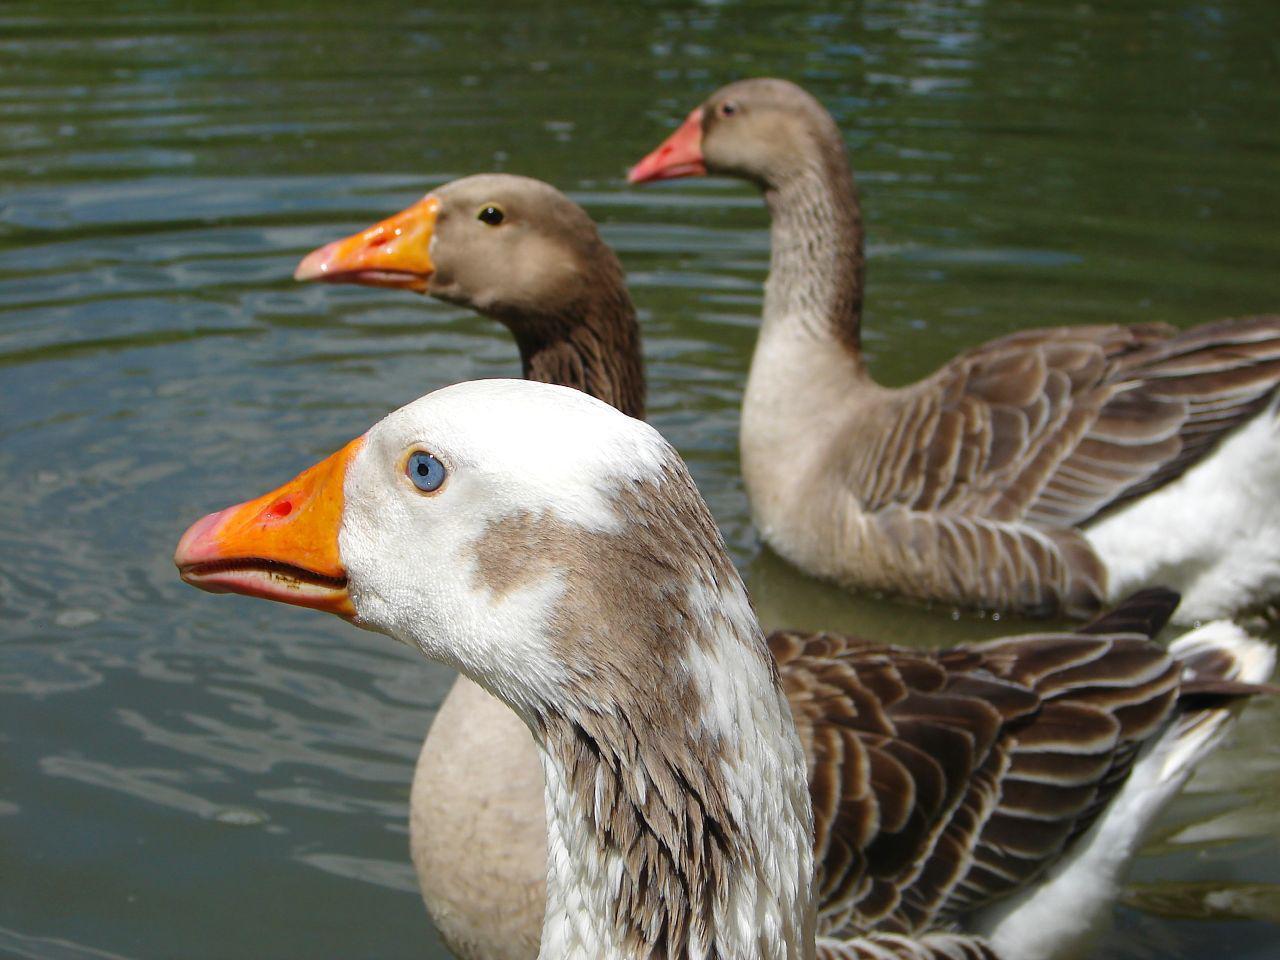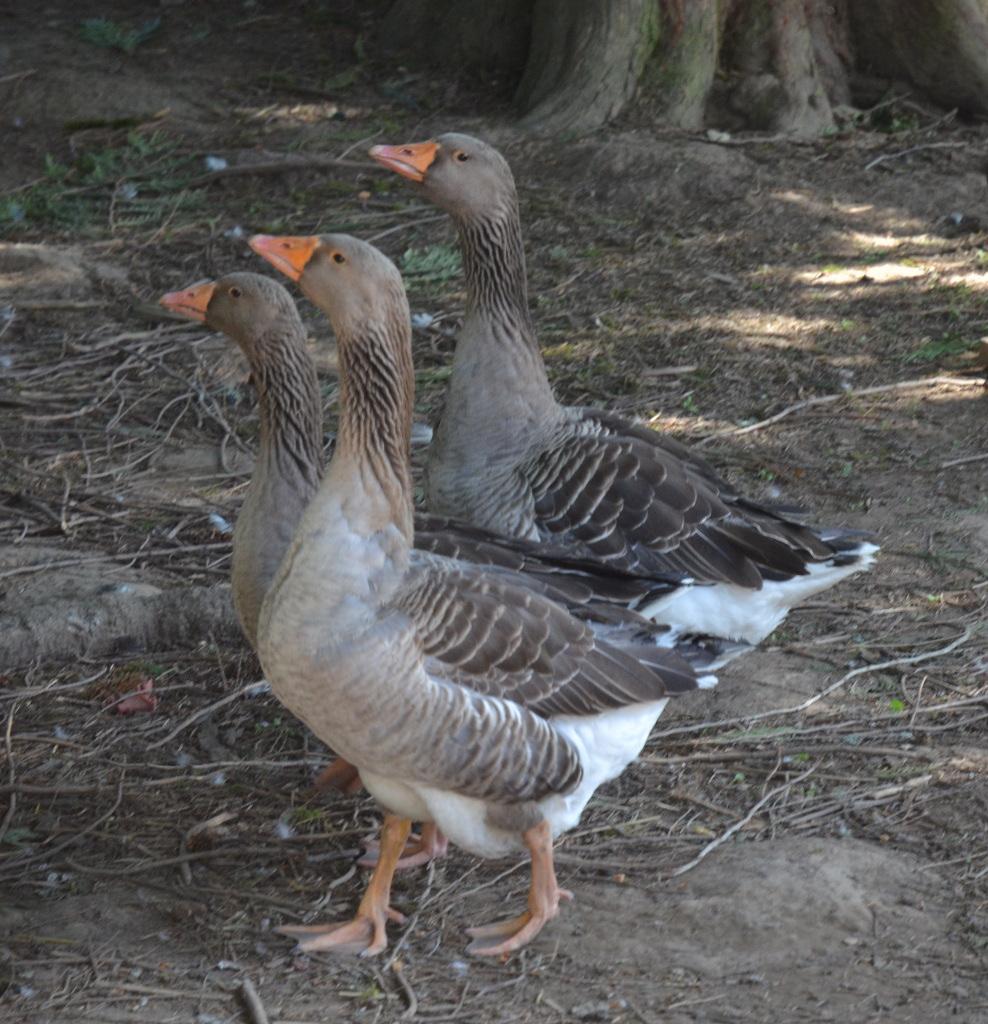The first image is the image on the left, the second image is the image on the right. Assess this claim about the two images: "There are exactly two ducks.". Correct or not? Answer yes or no. No. The first image is the image on the left, the second image is the image on the right. For the images displayed, is the sentence "An image shows one black-beaked goose standing on the water's edge." factually correct? Answer yes or no. No. 